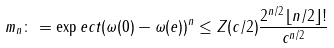Convert formula to latex. <formula><loc_0><loc_0><loc_500><loc_500>m _ { n } \colon = \exp e c t { ( \omega ( 0 ) - \omega ( e ) ) ^ { n } } \leq Z ( { c } / 2 ) \frac { 2 ^ { n / 2 } \lfloor n / 2 \rfloor ! } { c ^ { n / 2 } }</formula> 